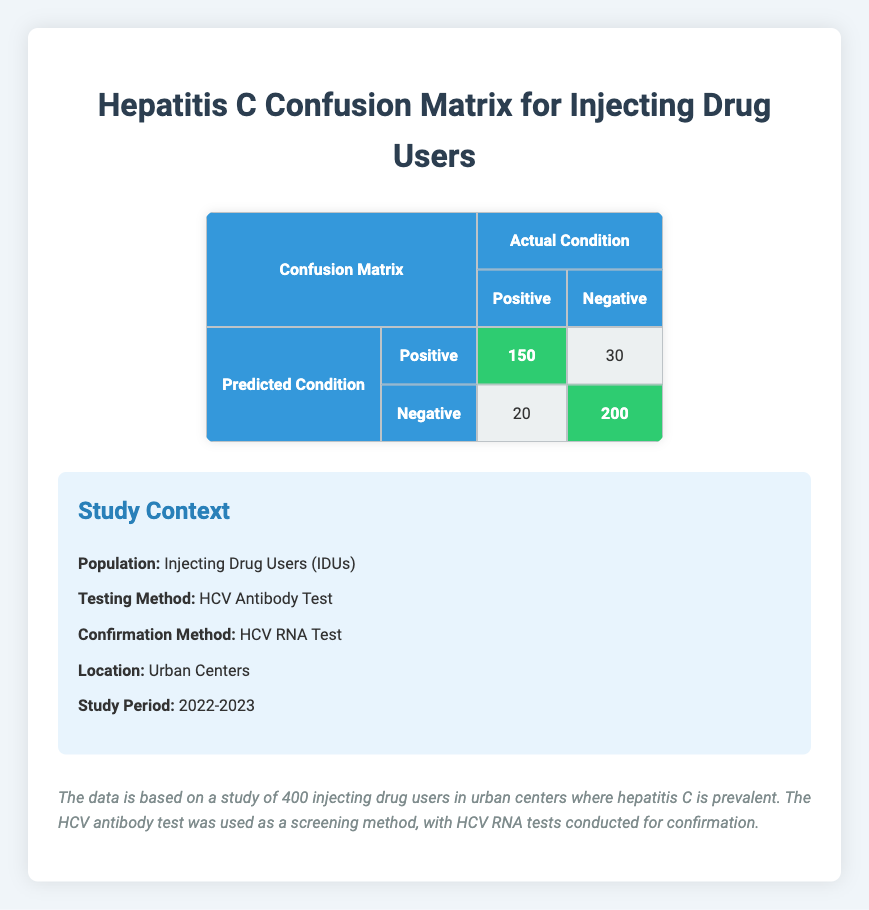What is the number of true positive cases in the confusion matrix? The table shows that the number of true positive cases is specifically listed under the predicted positive condition for actual positive condition, which is 150.
Answer: 150 How many false negatives are reported in the study? In the confusion matrix, the false negatives are shown under the predicted negative condition for the actual positive condition, which is 20.
Answer: 20 What is the total number of participants in the study? The total number of participants can be calculated by summing all values in the confusion matrix: True Positive (150) + True Negative (200) + False Positive (30) + False Negative (20) = 400.
Answer: 400 Were there more true negatives than false positives? The table indicates that true negatives are 200 and false positives are 30. Since 200 is greater than 30, the answer is yes.
Answer: Yes What percentage of the cases tested positive were actually true positives? To find this, we divide the true positive cases (150) by the total number of predicted positive cases, which is the sum of true positives and false positives (150 + 30 = 180). Then, multiplying by 100 gives us (150 / 180) * 100 = 83.33%.
Answer: 83.33% What is the total number of false results (false positives and false negatives) in the study? The total number of false results can be calculated by summing false positives (30) and false negatives (20), which results in 30 + 20 = 50.
Answer: 50 How many actual negative cases were wrongly classified as positive? The number of actual negative cases that were wrongly classified as positive is the value of false positives, which is 30 according to the table.
Answer: 30 What is the specificity of the HCV antibody test in this study? Specificity is calculated as the True Negative rate, which is True Negatives divided by the sum of True Negatives and False Positives. Here, it is 200 / (200 + 30) = 200 / 230 ≈ 0.8696, or 86.96%.
Answer: 86.96% How does the number of true positives compare to the number of true negatives? The confusion matrix shows that there are 150 true positives and 200 true negatives. Thus, true negatives are higher than true positives by 50.
Answer: True negatives are higher by 50 